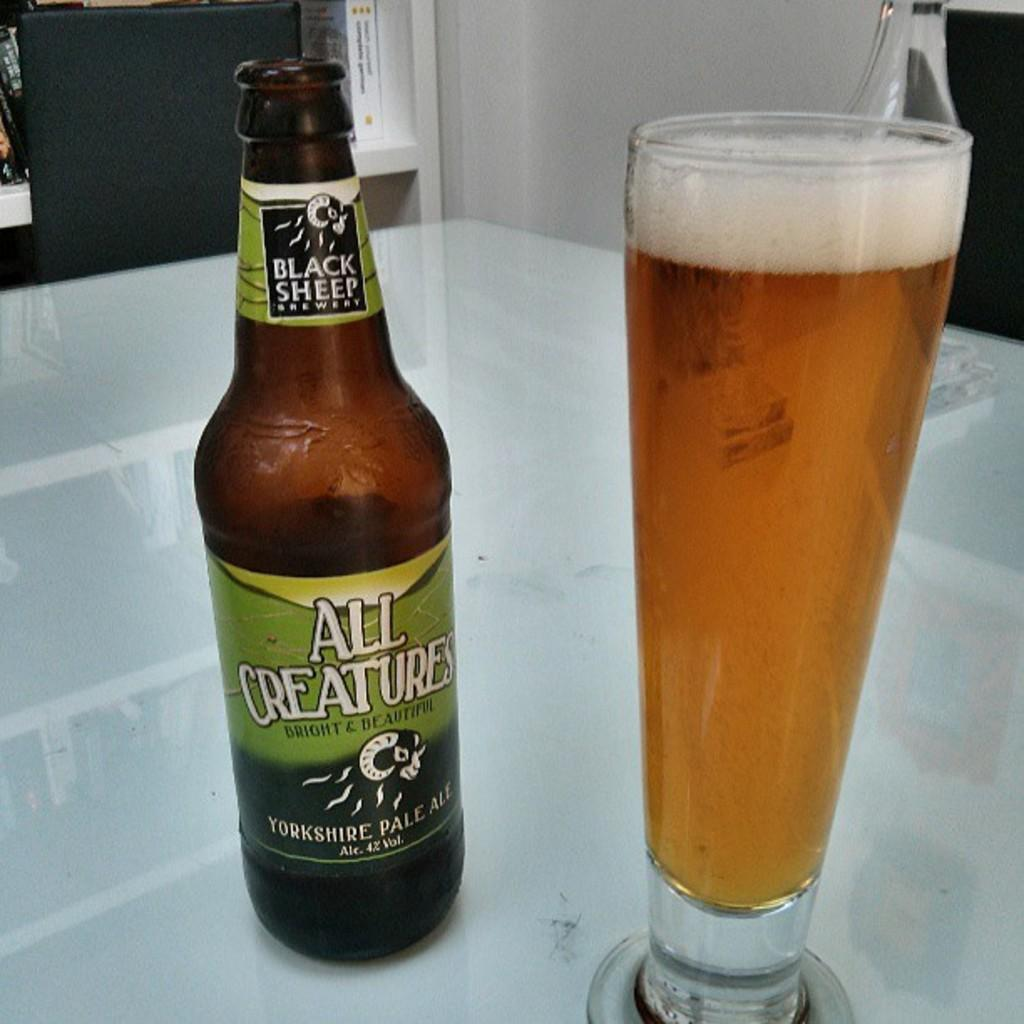<image>
Share a concise interpretation of the image provided. An open bottle of All Creatures from Black Sheep Brewery next to a full glass of beer. 